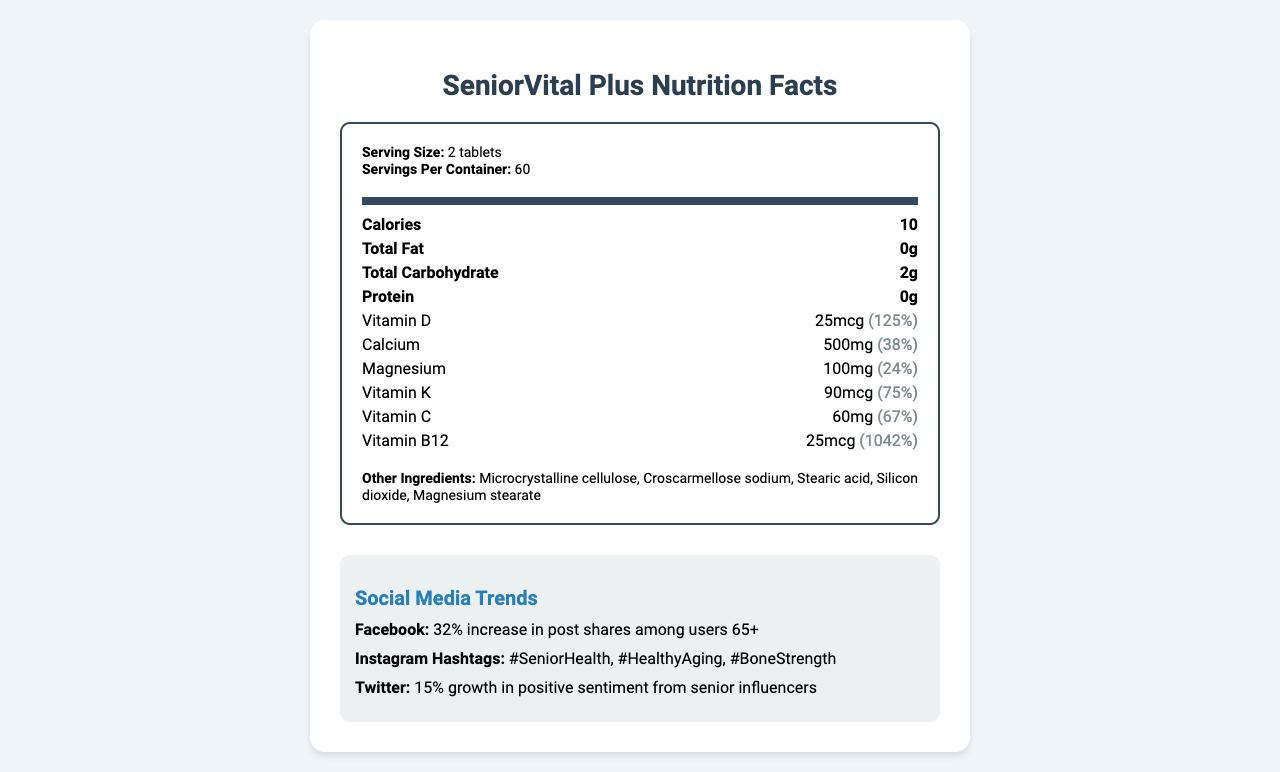what is the serving size of SeniorVital Plus? The serving size is specified in the top section of the nutrition label as 'Serving Size: 2 tablets'.
Answer: 2 tablets how much calcium does one serving provide? The amount of calcium per serving is listed under the nutrients as 'Calcium: 500mg'.
Answer: 500mg what is the percentage daily value of vitamin d in SeniorVital Plus? The percentage daily value for Vitamin D is specified as 'Vitamin D: 25mcg (125%)'.
Answer: 125% which social media platform saw a 32% increase in post shares among users 65+? The social media trends section mentions 'Facebook: 32% increase in post shares among users 65+'.
Answer: Facebook name two key nutrients in the supplement that support bone health. Vitamin D and Calcium are well-known for supporting bone health and are prominently listed in the nutrient section.
Answer: Vitamin D and Calcium what allergens are present in SeniorVital Plus? A. Dairy B. Soy C. Gluten The allergen information states 'Contains soy'.
Answer: B how many servings are there per container of SeniorVital Plus? A. 30 B. 60 C. 90 The nutrition label notes 'Servings Per Container: 60'.
Answer: B how much vitamin B12 does one serving contain? The nutrient section lists 'Vitamin B12: 25mcg'.
Answer: 25mcg does SeniorVital Plus include magnesium stearate among its ingredients? The other ingredients section explicitly lists 'Magnesium stearate' as one of its components.
Answer: Yes what is the total carbohydrate content per serving? The total carbohydrate content is listed in the main nutrition facts: 'Total Carbohydrate: 2g'.
Answer: 2g summarize the main purpose and key information provided by this document. The nutrition label breaks down the key nutrients and their benefits, while also including relevant allergen and ingredient details. The social media trends and additional usage information provide context into the supplement's popularity and appropriate usage.
Answer: The document provides the nutritional facts for SeniorVital Plus, a senior-focused multivitamin supplement. It lists the serving size, calories, major nutrients with their amounts and daily values, allergen information, and other ingredients. Additionally, it highlights social media trends, storage instructions, usage instructions, and key benefits of the supplement. what are the primary social media hashtags related to SeniorVital Plus on Instagram? The social media trends section mentions these three hashtags for Instagram engagement.
Answer: #SeniorHealth, #HealthyAging, #BoneStrength what instructions are provided for the storage of SeniorVital Plus? The storage instructions specifically state 'Store in a cool, dry place away from direct sunlight'.
Answer: Store in a cool, dry place away from direct sunlight how does the presence of vitamin K in SeniorVital Plus contribute to senior health? The document lists the amount and daily value of vitamin K but does not provide detailed information on how it specifically contributes to senior health.
Answer: Not enough information what is the average user rating for SeniorVital Plus based on online reviews? The online reviews section indicates 'average rating: 4.7'.
Answer: 4.7 